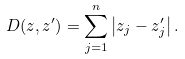<formula> <loc_0><loc_0><loc_500><loc_500>D ( { z } , { z ^ { \prime } } ) = \sum _ { j = 1 } ^ { n } \left | z _ { j } - z _ { j } ^ { \prime } \right | .</formula> 